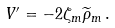<formula> <loc_0><loc_0><loc_500><loc_500>V ^ { \prime } = - 2 \zeta _ { m } \widetilde { \rho } _ { m } \, .</formula> 